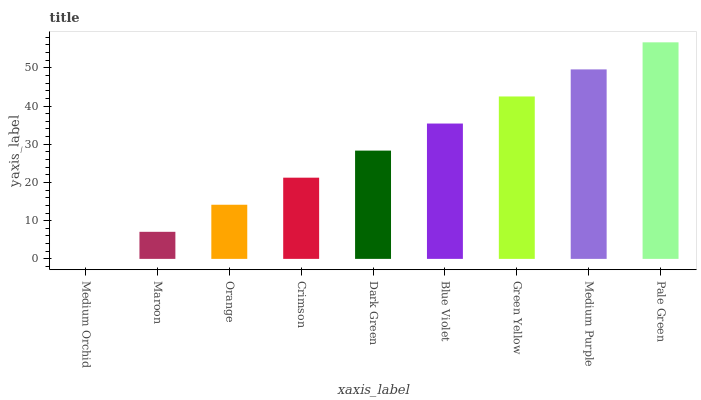Is Medium Orchid the minimum?
Answer yes or no. Yes. Is Pale Green the maximum?
Answer yes or no. Yes. Is Maroon the minimum?
Answer yes or no. No. Is Maroon the maximum?
Answer yes or no. No. Is Maroon greater than Medium Orchid?
Answer yes or no. Yes. Is Medium Orchid less than Maroon?
Answer yes or no. Yes. Is Medium Orchid greater than Maroon?
Answer yes or no. No. Is Maroon less than Medium Orchid?
Answer yes or no. No. Is Dark Green the high median?
Answer yes or no. Yes. Is Dark Green the low median?
Answer yes or no. Yes. Is Pale Green the high median?
Answer yes or no. No. Is Crimson the low median?
Answer yes or no. No. 